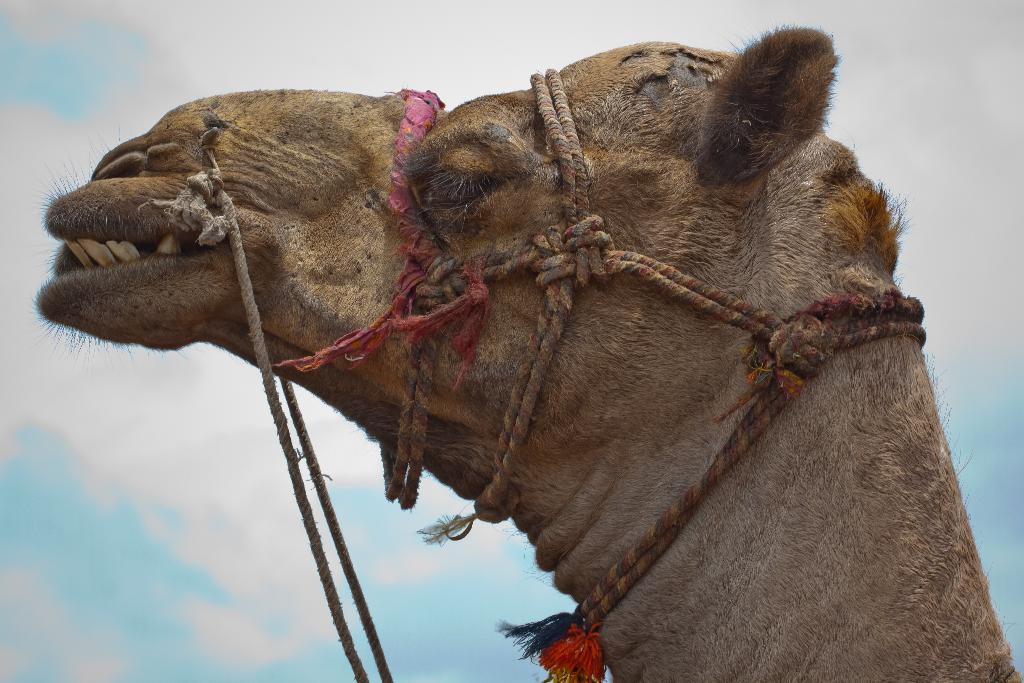What animal is present in the image? There is a camel in the image. What is the camel doing in the image? The camel's mouth is open. Can you describe the camel's teeth? The camel's teeth are visible in the image. What can be seen in the background of the image? The sky is visible in the image. What is the color of the sky in the image? The sky is blue in color. How would you describe the cloud coverage in the image? The sky is almost cloudy. What type of club can be seen in the image? There is no club present in the image; it features a camel with an open mouth and visible teeth. Is the camel feeling hot in the image? There is no indication of the camel's temperature in the image, so it cannot be determined from the picture. 